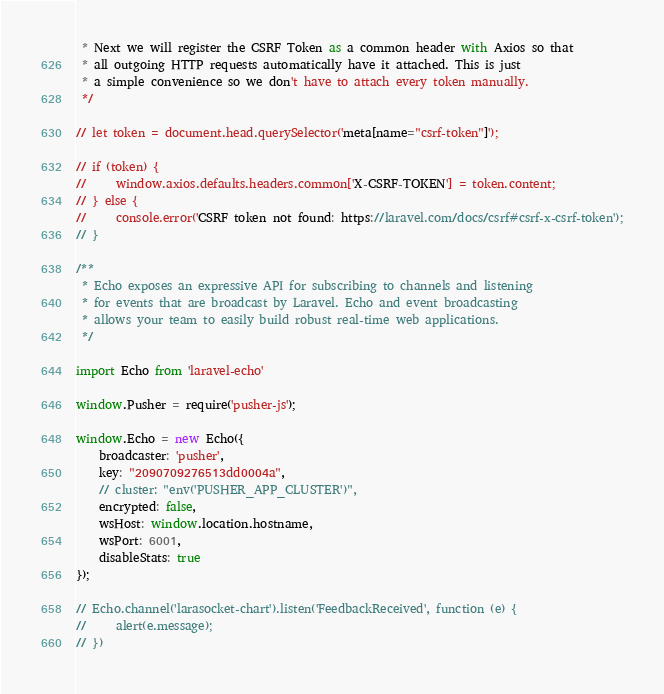Convert code to text. <code><loc_0><loc_0><loc_500><loc_500><_JavaScript_> * Next we will register the CSRF Token as a common header with Axios so that
 * all outgoing HTTP requests automatically have it attached. This is just
 * a simple convenience so we don't have to attach every token manually.
 */

// let token = document.head.querySelector('meta[name="csrf-token"]');

// if (token) {
//     window.axios.defaults.headers.common['X-CSRF-TOKEN'] = token.content;
// } else {
//     console.error('CSRF token not found: https://laravel.com/docs/csrf#csrf-x-csrf-token');
// }

/**
 * Echo exposes an expressive API for subscribing to channels and listening
 * for events that are broadcast by Laravel. Echo and event broadcasting
 * allows your team to easily build robust real-time web applications.
 */

import Echo from 'laravel-echo'

window.Pusher = require('pusher-js');

window.Echo = new Echo({
    broadcaster: 'pusher',
    key: "2090709276513dd0004a",
    // cluster: "env('PUSHER_APP_CLUSTER')",
    encrypted: false,
    wsHost: window.location.hostname,
    wsPort: 6001,
    disableStats: true
});

// Echo.channel('larasocket-chart').listen('FeedbackReceived', function (e) {
//     alert(e.message);
// })
</code> 